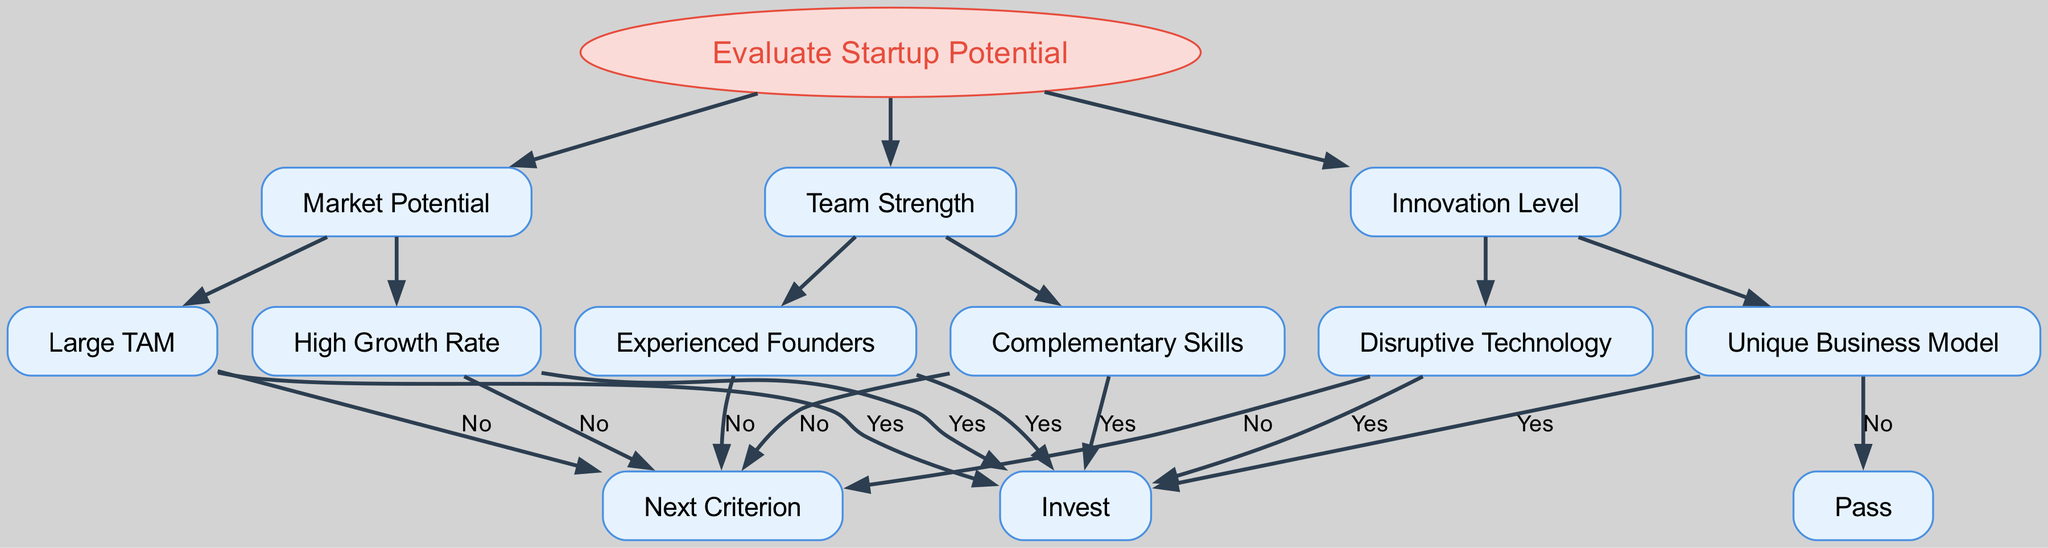What is the root of the decision tree? The root of the decision tree is labeled "Evaluate Startup Potential," which represents the main decision criterion.
Answer: Evaluate Startup Potential How many main criteria are evaluated in this diagram? There are three main criteria evaluated in the diagram: Market Potential, Team Strength, and Innovation Level.
Answer: Three What happens if a startup has a Large TAM? If a startup has a Large TAM, the next step according to the diagram is to invest, as indicated by the "Invest" node.
Answer: Invest What is the outcome if the team has Complementary Skills? If the team has Complementary Skills, then the outcome is to invest as well, which is stated in the "Invest" node under that criterion.
Answer: Invest If the startup has a Unique Business Model, what is the next step? If the startup has a Unique Business Model, according to the decision tree, the next step is to pass, as indicated by the "Pass" node.
Answer: Pass What are the two considerations under Market Potential? The two considerations under Market Potential are "Large TAM" and "High Growth Rate." They represent two different aspects of market evaluation.
Answer: Large TAM, High Growth Rate Which node indicates that you should not invest? The node labeled "Next Criterion" indicates that if certain conditions are not met, you would not invest; specifically, it appears after criteria evaluation that does not qualify for investment.
Answer: Next Criterion What happens at the "Disruptive Technology" node? According to the diagram, the outcome at the "Disruptive Technology" node is to invest if the condition is met.
Answer: Invest Which sub-category directly leads to a 'Pass' decision? The sub-category that directly leads to a 'Pass' decision is "Unique Business Model." If this criterion is evaluated, the decision is to pass.
Answer: Unique Business Model 